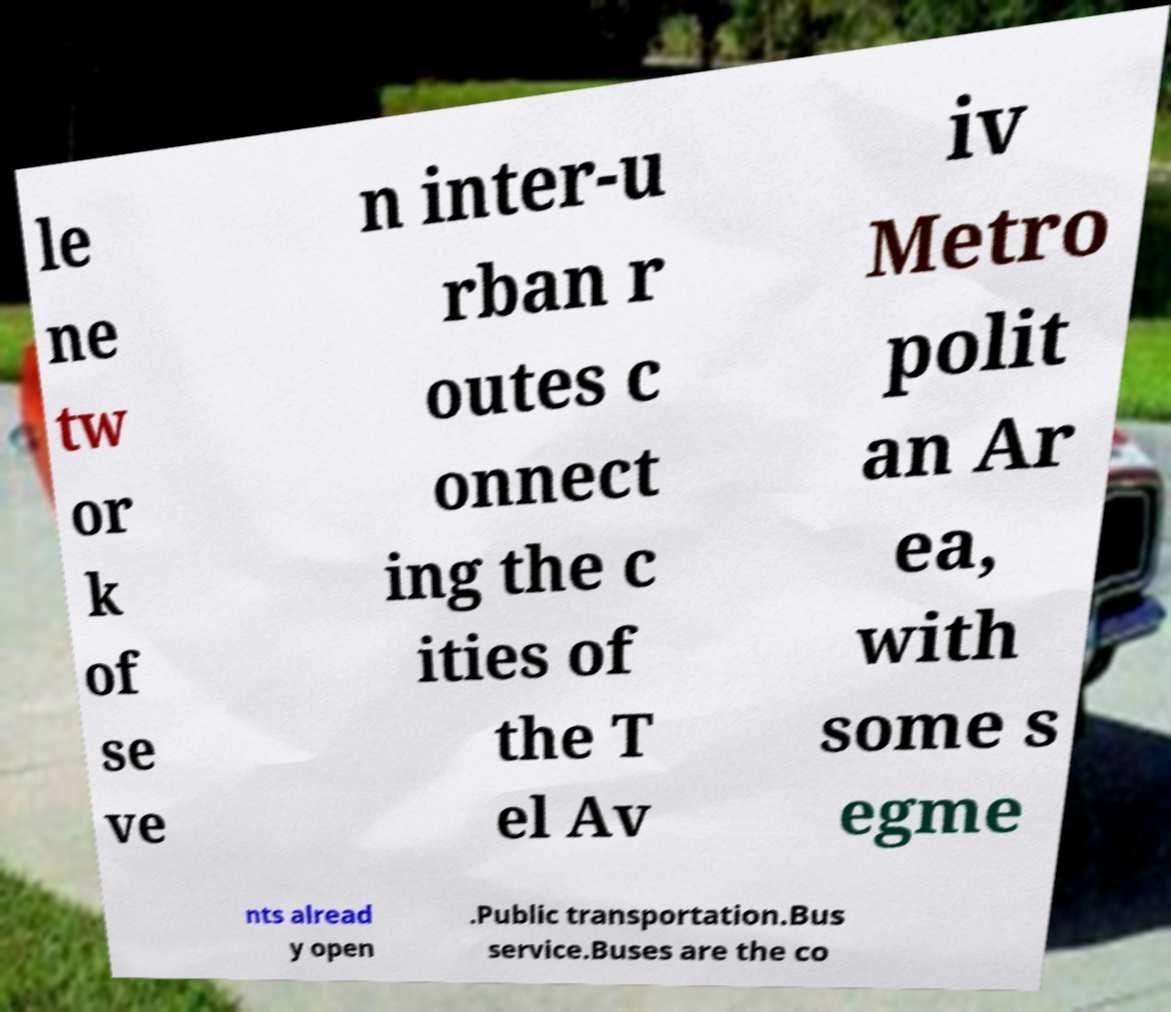Please read and relay the text visible in this image. What does it say? le ne tw or k of se ve n inter-u rban r outes c onnect ing the c ities of the T el Av iv Metro polit an Ar ea, with some s egme nts alread y open .Public transportation.Bus service.Buses are the co 